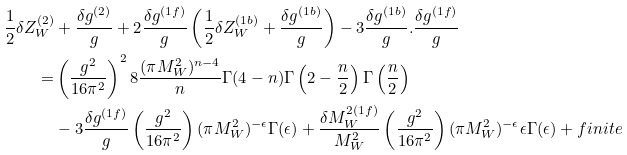Convert formula to latex. <formula><loc_0><loc_0><loc_500><loc_500>\frac { 1 } { 2 } \delta Z _ { W } ^ { ( 2 ) } & + \frac { \delta g ^ { ( 2 ) } } { g } + 2 \frac { \delta g ^ { ( 1 f ) } } { g } \left ( \frac { 1 } { 2 } \delta Z _ { W } ^ { ( 1 b ) } + \frac { \delta g ^ { ( 1 b ) } } { g } \right ) - 3 \frac { \delta g ^ { ( 1 b ) } } { g } . \frac { \delta g ^ { ( 1 f ) } } { g } \\ = & \left ( \frac { g ^ { 2 } } { 1 6 \pi ^ { 2 } } \right ) ^ { 2 } 8 \frac { ( \pi M _ { W } ^ { 2 } ) ^ { n - 4 } } { n } \Gamma ( 4 - n ) \Gamma \left ( 2 - \frac { n } { 2 } \right ) \Gamma \left ( \frac { n } { 2 } \right ) \\ & - 3 \frac { \delta g ^ { ( 1 f ) } } { g } \left ( \frac { g ^ { 2 } } { 1 6 \pi ^ { 2 } } \right ) ( \pi M _ { W } ^ { 2 } ) ^ { - \epsilon } \Gamma ( \epsilon ) + \frac { \delta M _ { W } ^ { 2 ( 1 f ) } } { M _ { W } ^ { 2 } } \left ( \frac { g ^ { 2 } } { 1 6 \pi ^ { 2 } } \right ) ( \pi M _ { W } ^ { 2 } ) ^ { - \epsilon } \epsilon \Gamma ( \epsilon ) + f i n i t e</formula> 